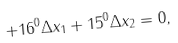Convert formula to latex. <formula><loc_0><loc_0><loc_500><loc_500>+ 1 6 ^ { 0 } \Delta x _ { 1 } + 1 5 ^ { 0 } \Delta x _ { 2 } = 0 ,</formula> 